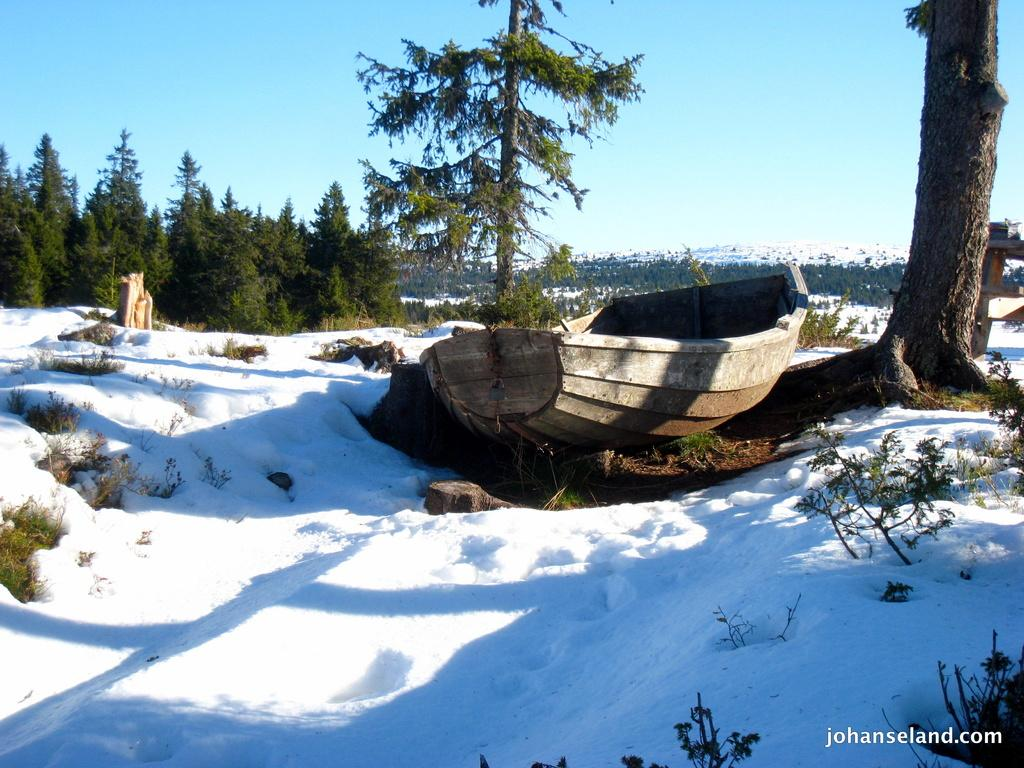What is the main subject in the center of the image? There is a boat in the center of the image. Where is the boat located? The boat is on the ground. What can be seen in the background of the image? There are trees, hills, and the sky visible in the background of the image. What is present at the bottom of the image? There are plants and some text at the bottom of the image. What type of rhythm can be heard coming from the horses in the image? There are no horses present in the image, so it is not possible to determine the rhythm. 